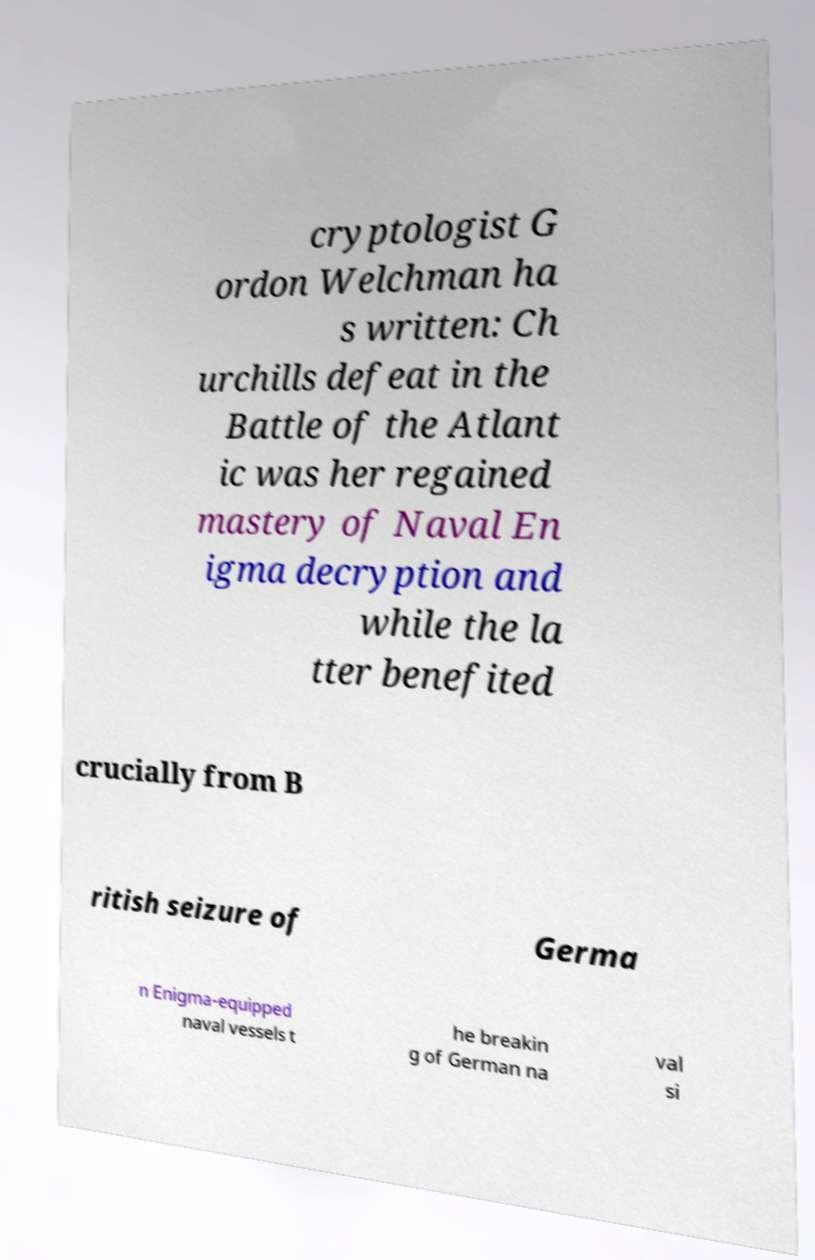I need the written content from this picture converted into text. Can you do that? cryptologist G ordon Welchman ha s written: Ch urchills defeat in the Battle of the Atlant ic was her regained mastery of Naval En igma decryption and while the la tter benefited crucially from B ritish seizure of Germa n Enigma-equipped naval vessels t he breakin g of German na val si 